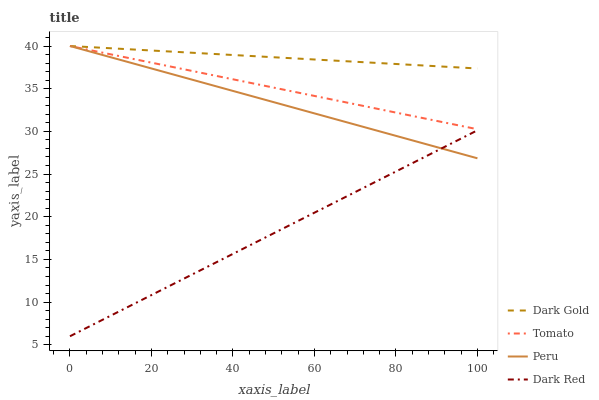Does Peru have the minimum area under the curve?
Answer yes or no. No. Does Peru have the maximum area under the curve?
Answer yes or no. No. Is Peru the smoothest?
Answer yes or no. No. Is Dark Red the roughest?
Answer yes or no. No. Does Peru have the lowest value?
Answer yes or no. No. Does Dark Red have the highest value?
Answer yes or no. No. Is Dark Red less than Tomato?
Answer yes or no. Yes. Is Dark Gold greater than Dark Red?
Answer yes or no. Yes. Does Dark Red intersect Tomato?
Answer yes or no. No. 